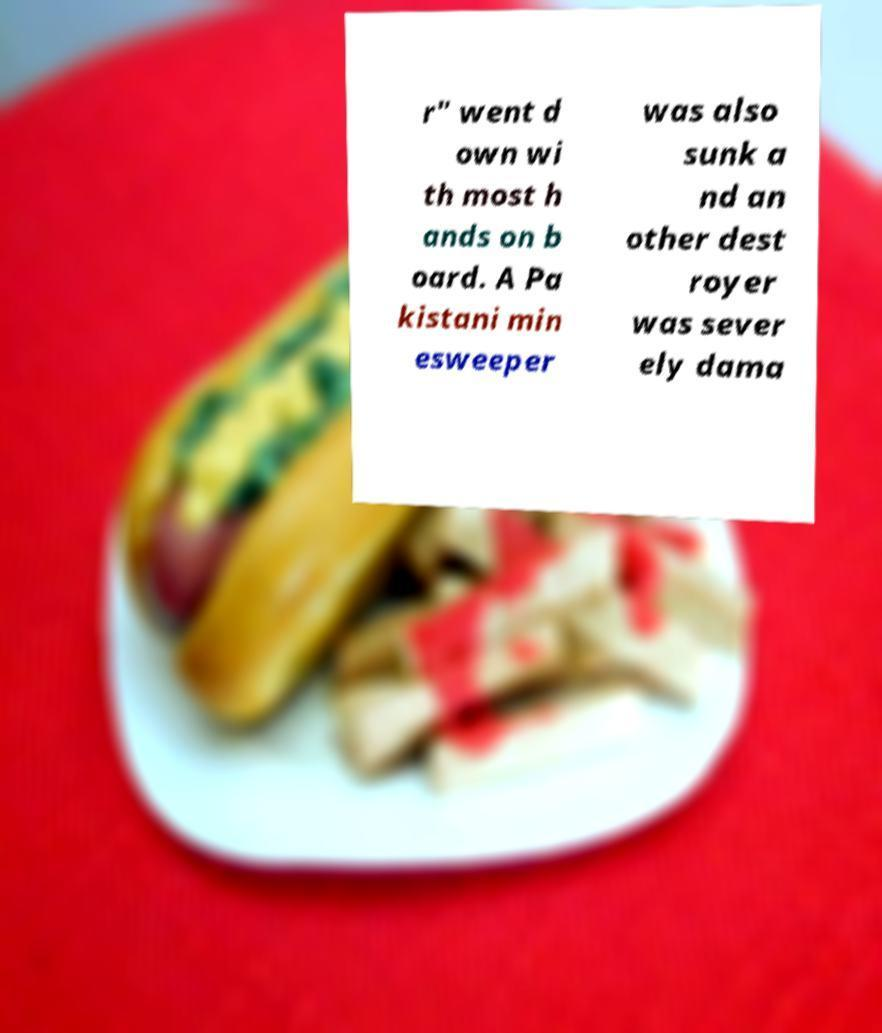For documentation purposes, I need the text within this image transcribed. Could you provide that? r" went d own wi th most h ands on b oard. A Pa kistani min esweeper was also sunk a nd an other dest royer was sever ely dama 